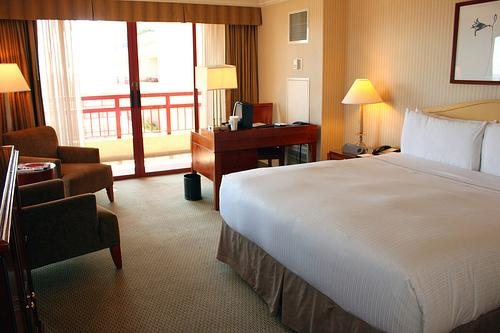How many windows or glass doors are there in the image, and what are their distinguishing features? There are two large window curtains and two sliding glass doors, which have a glass door leading to the terrace and a red railing on the balcony. Which objects in the image can be found near the bed? Objects near the bed include a lamp with a square shade, a black trash can, and two brown chairs. What is the total number of lamps in the bedroom, and do they have any unique attributes? There are three lamps in the bedroom, one of which has a distinctive square-shaped shade. What is the color of the trash can in the image, and where is it located? The trash can is black in color and is located beside the desk in the room. In the image, comment on the interaction between the chair and another object. There is a brown chair by the door, and it is placed across from the bed, indicating it could be used for sitting down and facing the bed. Give a sentiment analysis of the room based on the objects and their arrangement. The room feels cozy and well-organized, with a large bed and decorative elements like wall art and lamps; it provides a sense of comfort and relaxation. Using details from the image, evaluate the overall quality of the room in terms of aesthetics and functionality. The room appears to be well-designed and functional, with a spacious bed, comfortable furnishings, and adequate lighting from the lamps, all arranged in a visually appealing manner. Identify the elements of the image that are related to the wall decoration. There is a picture on the wall with a brown frame, a vent on the wall, and wallpaper on the wall. Identify the color and shape of the lamp shade in the image. The lamp shade is square in shape and its color appears to be white or off-white. Describe the appearance of the bed and any items on it. The bed is wide and large, with a white sheet on top, white pillows on the bed, tan bed skirt, and a large brown sheet as the bed covering. Which object is sitting on the table? lamp Can you please find the pink teddy bear sitting on the bed and describe its position in relation to the pillows? There is no mention of a pink teddy bear in the list of objects in the image. Using an interrogative sentence style creates a sense of curiosity and expectation that there is a pink teddy bear in the image, which is misleading. Describe the lamp shade in the bedroom. square and brown Please describe the bed's components in the bedroom. wide and large bed, white pillow cases, large brown sheet, white sheet on bed top, bed skirt around the bed, comforter on the bed Identify the two objects that have a glass material. glass door to terrace and sliding glass doors Describe the type of chairs in the bedroom. two brown chairs What is the color of the railing on the balcony? red What is the primary color of the sheets on the bed? white Do you notice the green curtains hanging by the sliding glass doors, and if so, can you describe their pattern? There is no mention of green curtains in the list of objects in the image. Using an interrogative sentence style with a conditional clause implies the existence of green curtains in the image, which is misleading. Please focus on the striped wallpaper behind the brown chair and tell me the two main colors used. No, it's not mentioned in the image. Pay close attention to the beautiful flower vase on the brown desk and tell me its color. There is no mention of a flower vase in the list of objects in the image. By using a declarative sentence style and calling the vase "beautiful," the instruction creates a false impression that there is a flower vase present in the image. What is the color and texture of the carpet on the floor? tan and smooth Can you describe the picture hanging above the bed? brown frame and small portrait Describe the object that has a vent feature. vent on the wall What is the color and material of the trash can near the desk? black and plastic Do the sliding glass doors lead to a terrace or a garden? terrace Observe the ornate chandelier hanging from the ceiling and describe its design intricacies. There is no mention of a chandelier in the list of objects in the image. The use of a declarative sentence style and the adjective "ornate" leads the reader to believe that there is a chandelier with intricate designs, which is not the case. How many pillows are on the bed? two white pillows Describe the desk's position in the room. in front of sliding glass doors What event is occurring in the bedroom? no specific event is occurring Do you see the elegant painting of a landscape in the room, and can you describe the colors used? There is no mention of an elegant landscape painting in the list of objects in the image. Using an interrogative sentence combined with a positive adjective ("elegant") creates a false impression of the presence of a landscape painting in the image. Is there an indication of wallpaper on the wall? yes What activity do the two chairs across from the bed suggest? sitting or relaxing Which object is trash receptacle in the room? black trash can near the desk 